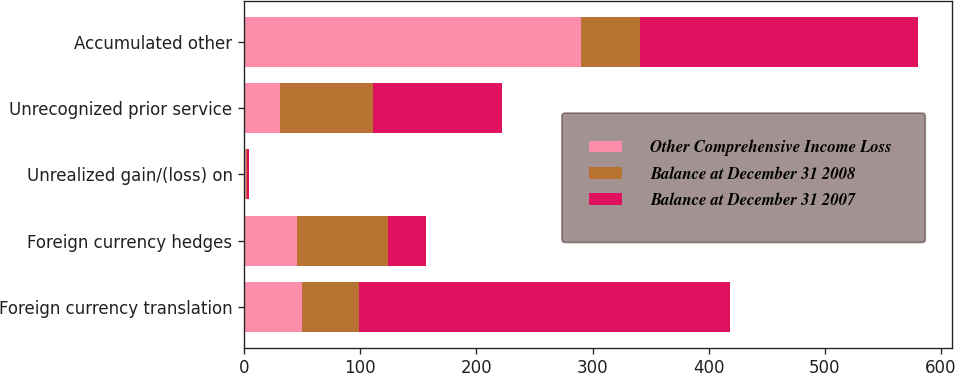Convert chart to OTSL. <chart><loc_0><loc_0><loc_500><loc_500><stacked_bar_chart><ecel><fcel>Foreign currency translation<fcel>Foreign currency hedges<fcel>Unrealized gain/(loss) on<fcel>Unrecognized prior service<fcel>Accumulated other<nl><fcel>Other Comprehensive Income Loss<fcel>49.85<fcel>45.4<fcel>1.9<fcel>31.2<fcel>290.3<nl><fcel>Balance at December 31 2008<fcel>49.4<fcel>78.4<fcel>0.6<fcel>79.9<fcel>50.3<nl><fcel>Balance at December 31 2007<fcel>319.4<fcel>33<fcel>1.3<fcel>111.1<fcel>240<nl></chart> 